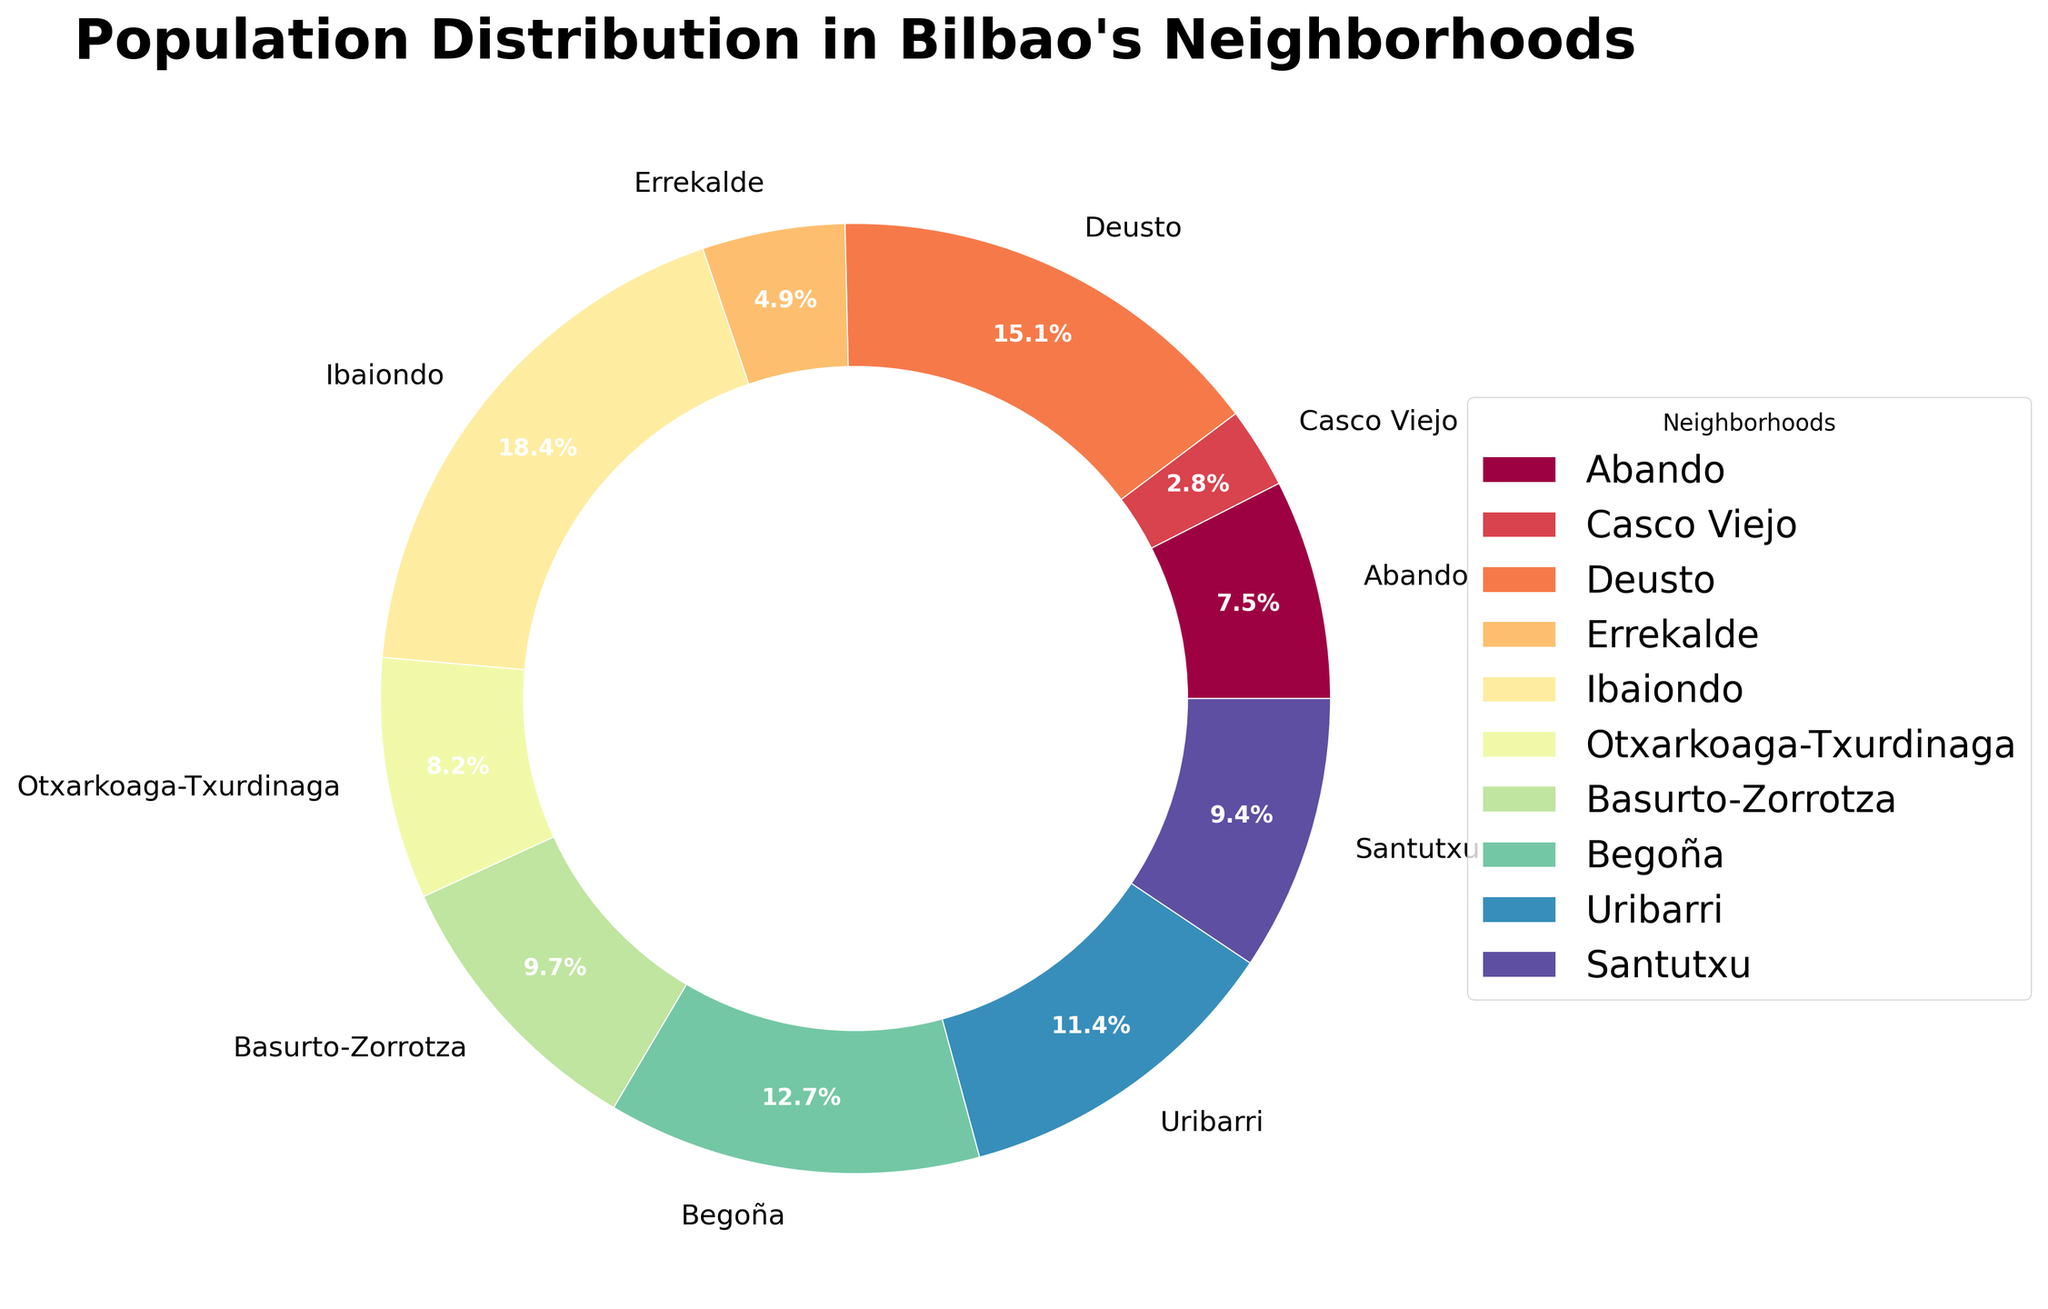Which neighborhood has the largest population? The pie chart segments labeled with the neighborhood names and their respective population percentages show that Ibaiondo has the largest slice.
Answer: Ibaiondo Which neighborhoods have a population greater than Abando? By examining the labeled population percentages, we can see which ones exceed Abando. Deusto, Ibaiondo, Begoña, Uribarri, and Basurto-Zorrotza have higher populations.
Answer: Deusto, Ibaiondo, Begoña, Uribarri, Basurto-Zorrotza What is the combined population percentage of Santutxu, Errekalde, and Casco Viejo? We add the individual population percentages shown for each neighborhood slice: Santutxu (10.0%) + Errekalde (5.2%) + Casco Viejo (2.9%).
Answer: 18.1% Which neighborhood has a larger population: Uribarri or Begoña? By looking at their respective portions in the pie chart, Uribarri has a slightly smaller segment compared to Begoña.
Answer: Begoña What is the sum of the populations of the three smallest neighborhoods? Identify the smallest slices in the chart, which are Casco Viejo, Errekalde, and Abando. Add their percentages: Casco Viejo (2.9%) + Errekalde (5.2%) + Abando (8.1%).
Answer: 16.2% Which neighborhood's population is closest to the average population of all neighborhoods? To get the average, sum the percentages and divide by 10. Then, compare this value to each neighborhood's percentage. The total percentage is 100%, so the average is 10%. Uribarri's 11.0% is the closest to this value.
Answer: Uribarri What is the population difference between Ibaiondo and Otxarkoaga-Txurdinaga? Identify the segments corresponding to Ibaiondo and Otxarkoaga-Txurdinaga, then subtract Otxarkoaga-Txurdinaga's percentage from Ibaiondo's: 20.7% - 9.2%.
Answer: 11.5% Which neighborhood has the smallest population? The smallest slice in the pie chart represents Casco Viejo.
Answer: Casco Viejo What percentage of the total population lives in Basurto-Zorrotza and Deusto combined? The slices labeled Basurto-Zorrotza and Deusto have percentages of 10.9% and 17.0%, respectively. Sum these values.
Answer: 27.9% Which neighborhood occupies the second largest segment in the pie chart? After Ibaiondo, the next largest slice belongs to Deusto.
Answer: Deusto 